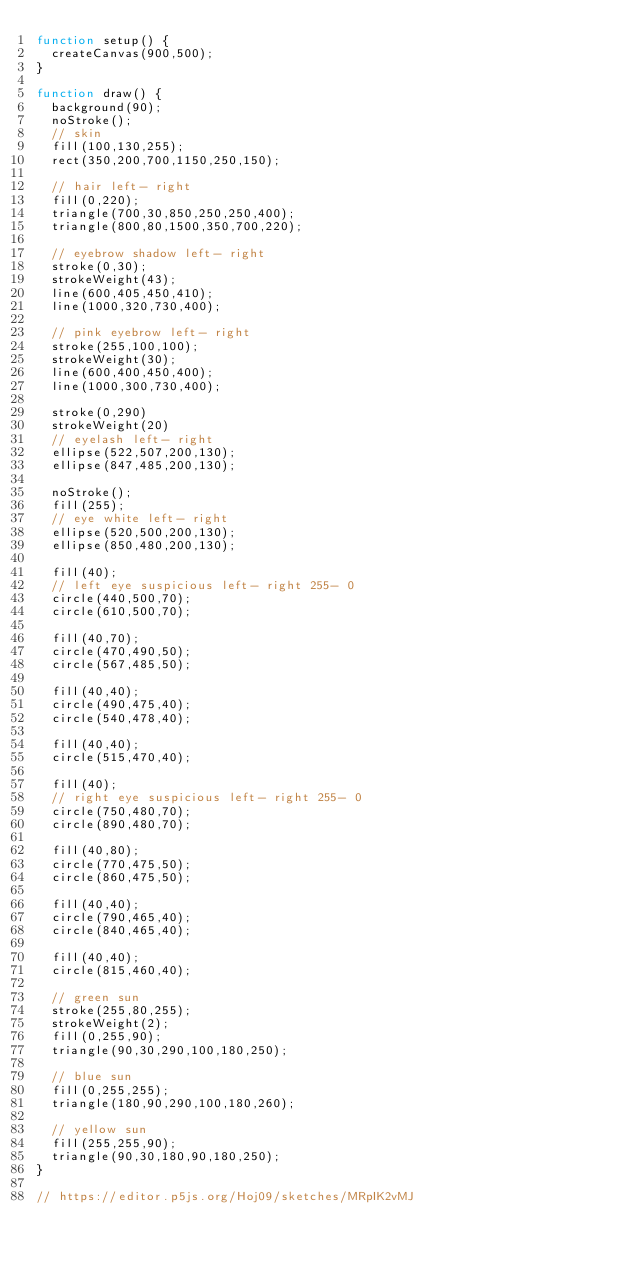<code> <loc_0><loc_0><loc_500><loc_500><_JavaScript_>function setup() {
  createCanvas(900,500);
}

function draw() {
  background(90);
  noStroke();
  // skin
  fill(100,130,255);
  rect(350,200,700,1150,250,150);
  
  // hair left- right
  fill(0,220);
  triangle(700,30,850,250,250,400);
  triangle(800,80,1500,350,700,220);
  
  // eyebrow shadow left- right
  stroke(0,30);
  strokeWeight(43);
  line(600,405,450,410);
  line(1000,320,730,400);
  
  // pink eyebrow left- right
  stroke(255,100,100);
  strokeWeight(30);
  line(600,400,450,400);
  line(1000,300,730,400);
  
  stroke(0,290)
  strokeWeight(20)
  // eyelash left- right
  ellipse(522,507,200,130);
  ellipse(847,485,200,130);
  
  noStroke();
  fill(255);
  // eye white left- right
  ellipse(520,500,200,130);
  ellipse(850,480,200,130);
  
  fill(40);
  // left eye suspicious left- right 255- 0
  circle(440,500,70);
  circle(610,500,70);
  
  fill(40,70);
  circle(470,490,50);
  circle(567,485,50);
  
  fill(40,40);
  circle(490,475,40);
  circle(540,478,40);
  
  fill(40,40);
  circle(515,470,40);
  
  fill(40);
  // right eye suspicious left- right 255- 0
  circle(750,480,70);
  circle(890,480,70);
  
  fill(40,80);
  circle(770,475,50);
  circle(860,475,50);
  
  fill(40,40);
  circle(790,465,40);
  circle(840,465,40);
  
  fill(40,40);
  circle(815,460,40);
  
  // green sun
  stroke(255,80,255);
  strokeWeight(2);
  fill(0,255,90);
  triangle(90,30,290,100,180,250);
  
  // blue sun
  fill(0,255,255);
  triangle(180,90,290,100,180,260);
  
  // yellow sun
  fill(255,255,90);
  triangle(90,30,180,90,180,250);
}

// https://editor.p5js.org/Hoj09/sketches/MRpIK2vMJ</code> 